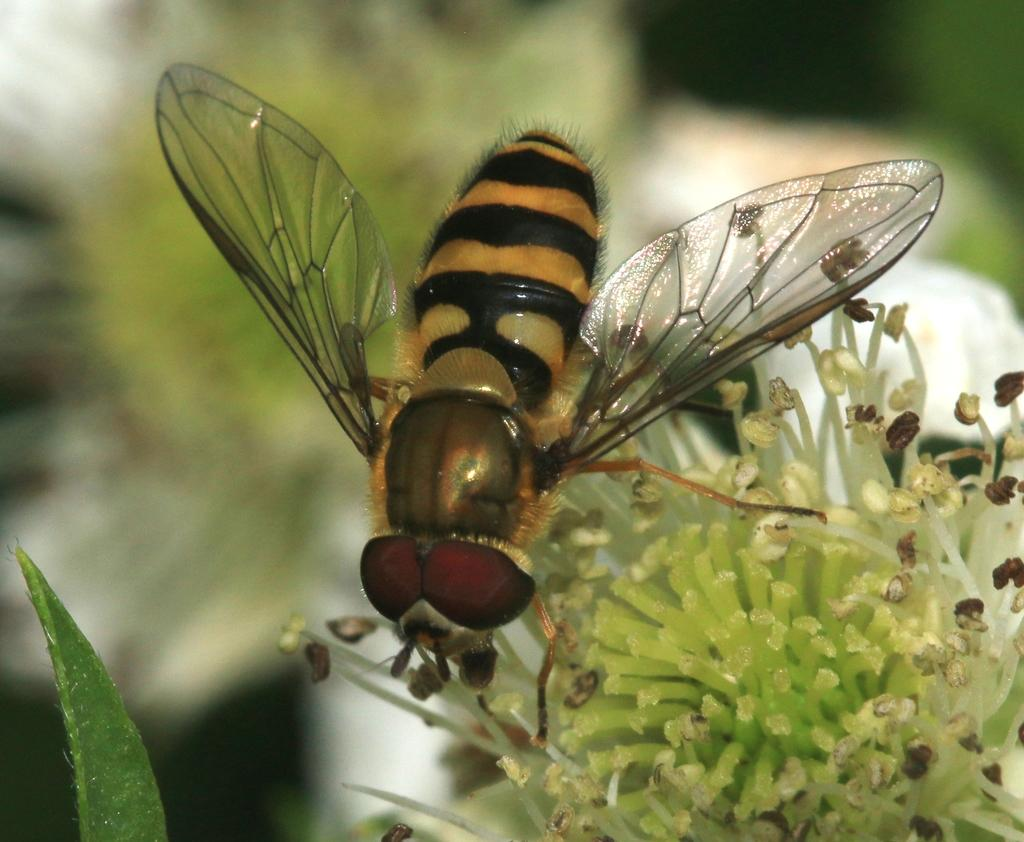What is present in the image? There is a plant and an insect on the plant in the image. Can you describe the insect? The insect has orange and black colors. How is the background of the image? The background of the image is slightly blurry. What type of destruction is the desk causing to the pickle in the image? There is no desk or pickle present in the image; it features a plant with an insect on it. 